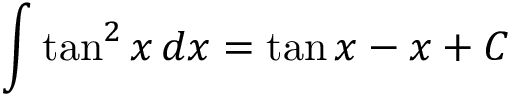Convert formula to latex. <formula><loc_0><loc_0><loc_500><loc_500>\int \tan ^ { 2 } x \, d x = \tan x - x + C</formula> 